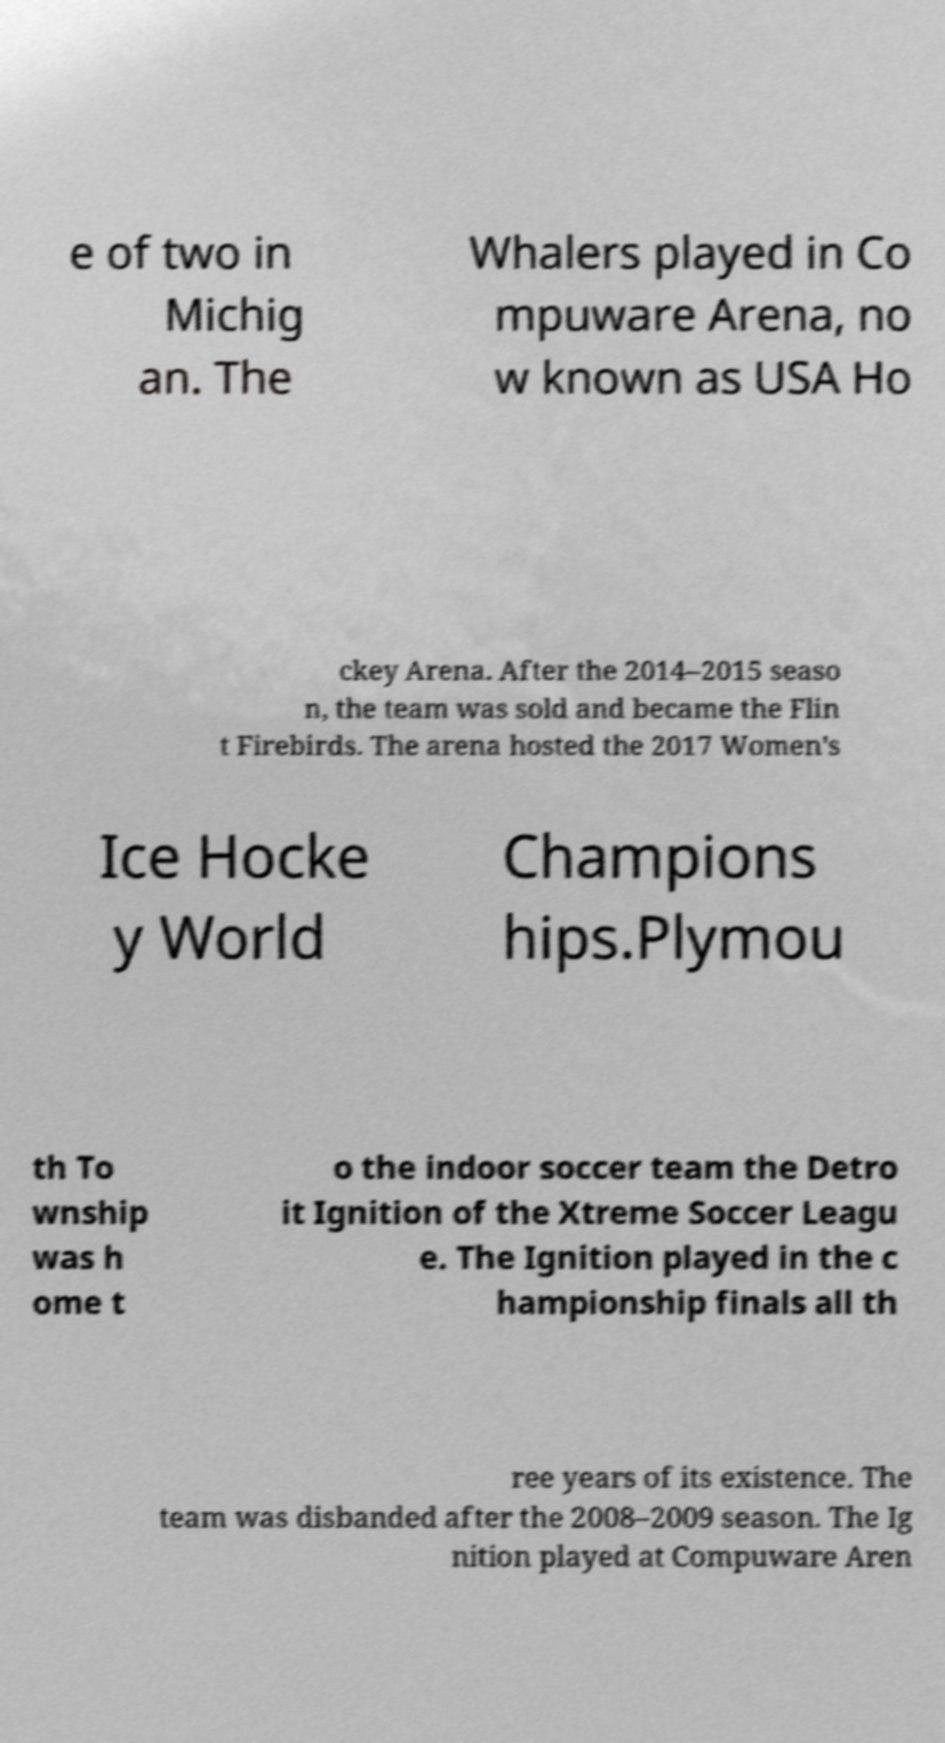Please read and relay the text visible in this image. What does it say? e of two in Michig an. The Whalers played in Co mpuware Arena, no w known as USA Ho ckey Arena. After the 2014–2015 seaso n, the team was sold and became the Flin t Firebirds. The arena hosted the 2017 Women's Ice Hocke y World Champions hips.Plymou th To wnship was h ome t o the indoor soccer team the Detro it Ignition of the Xtreme Soccer Leagu e. The Ignition played in the c hampionship finals all th ree years of its existence. The team was disbanded after the 2008–2009 season. The Ig nition played at Compuware Aren 